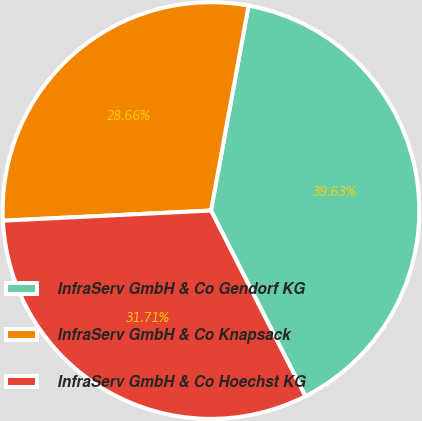<chart> <loc_0><loc_0><loc_500><loc_500><pie_chart><fcel>InfraServ GmbH & Co Gendorf KG<fcel>InfraServ GmbH & Co Knapsack<fcel>InfraServ GmbH & Co Hoechst KG<nl><fcel>39.63%<fcel>28.66%<fcel>31.71%<nl></chart> 